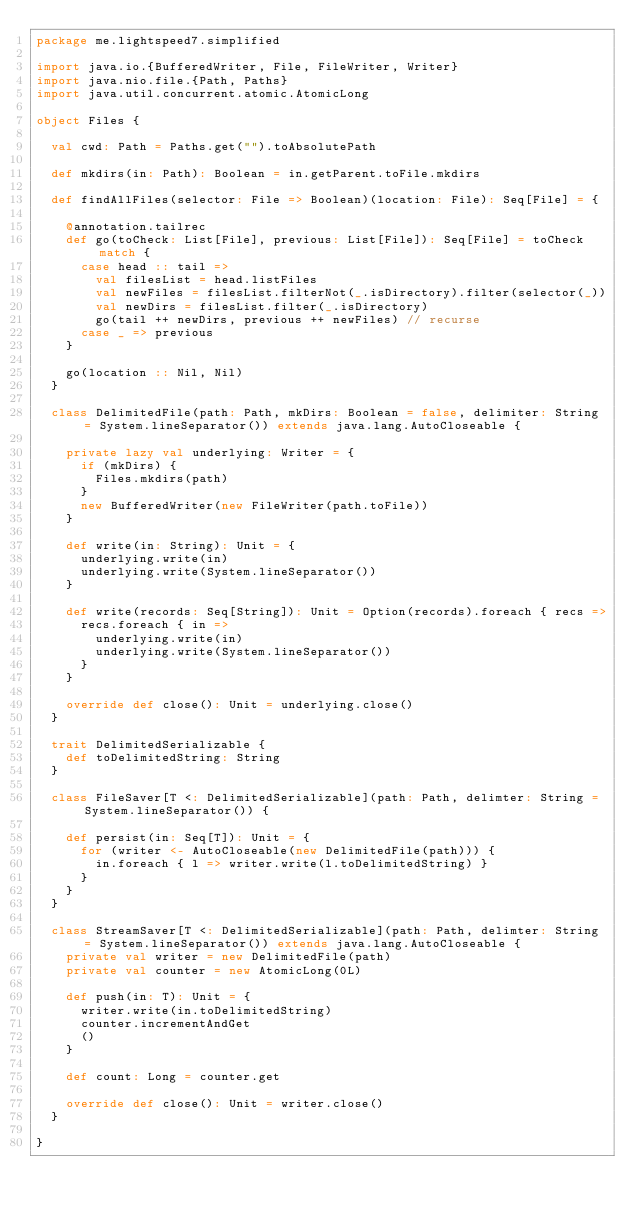Convert code to text. <code><loc_0><loc_0><loc_500><loc_500><_Scala_>package me.lightspeed7.simplified

import java.io.{BufferedWriter, File, FileWriter, Writer}
import java.nio.file.{Path, Paths}
import java.util.concurrent.atomic.AtomicLong

object Files {

  val cwd: Path = Paths.get("").toAbsolutePath

  def mkdirs(in: Path): Boolean = in.getParent.toFile.mkdirs

  def findAllFiles(selector: File => Boolean)(location: File): Seq[File] = {

    @annotation.tailrec
    def go(toCheck: List[File], previous: List[File]): Seq[File] = toCheck match {
      case head :: tail =>
        val filesList = head.listFiles
        val newFiles = filesList.filterNot(_.isDirectory).filter(selector(_))
        val newDirs = filesList.filter(_.isDirectory)
        go(tail ++ newDirs, previous ++ newFiles) // recurse
      case _ => previous
    }

    go(location :: Nil, Nil)
  }

  class DelimitedFile(path: Path, mkDirs: Boolean = false, delimiter: String = System.lineSeparator()) extends java.lang.AutoCloseable {

    private lazy val underlying: Writer = {
      if (mkDirs) {
        Files.mkdirs(path)
      }
      new BufferedWriter(new FileWriter(path.toFile))
    }

    def write(in: String): Unit = {
      underlying.write(in)
      underlying.write(System.lineSeparator())
    }

    def write(records: Seq[String]): Unit = Option(records).foreach { recs =>
      recs.foreach { in =>
        underlying.write(in)
        underlying.write(System.lineSeparator())
      }
    }

    override def close(): Unit = underlying.close()
  }

  trait DelimitedSerializable {
    def toDelimitedString: String
  }

  class FileSaver[T <: DelimitedSerializable](path: Path, delimter: String = System.lineSeparator()) {

    def persist(in: Seq[T]): Unit = {
      for (writer <- AutoCloseable(new DelimitedFile(path))) {
        in.foreach { l => writer.write(l.toDelimitedString) }
      }
    }
  }

  class StreamSaver[T <: DelimitedSerializable](path: Path, delimter: String = System.lineSeparator()) extends java.lang.AutoCloseable {
    private val writer = new DelimitedFile(path)
    private val counter = new AtomicLong(0L)

    def push(in: T): Unit = {
      writer.write(in.toDelimitedString)
      counter.incrementAndGet
      ()
    }

    def count: Long = counter.get

    override def close(): Unit = writer.close()
  }

}
</code> 